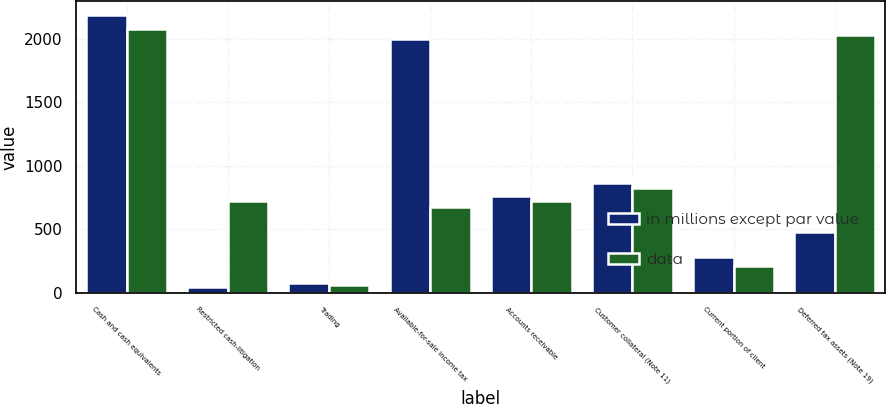Convert chart. <chart><loc_0><loc_0><loc_500><loc_500><stacked_bar_chart><ecel><fcel>Cash and cash equivalents<fcel>Restricted cash-litigation<fcel>Trading<fcel>Available-for-sale Income tax<fcel>Accounts receivable<fcel>Customer collateral (Note 11)<fcel>Current portion of client<fcel>Deferred tax assets (Note 19)<nl><fcel>in millions except par value<fcel>2186<fcel>49<fcel>75<fcel>1994<fcel>761<fcel>866<fcel>282<fcel>481<nl><fcel>data<fcel>2074<fcel>723<fcel>66<fcel>677<fcel>723<fcel>823<fcel>209<fcel>2027<nl></chart> 